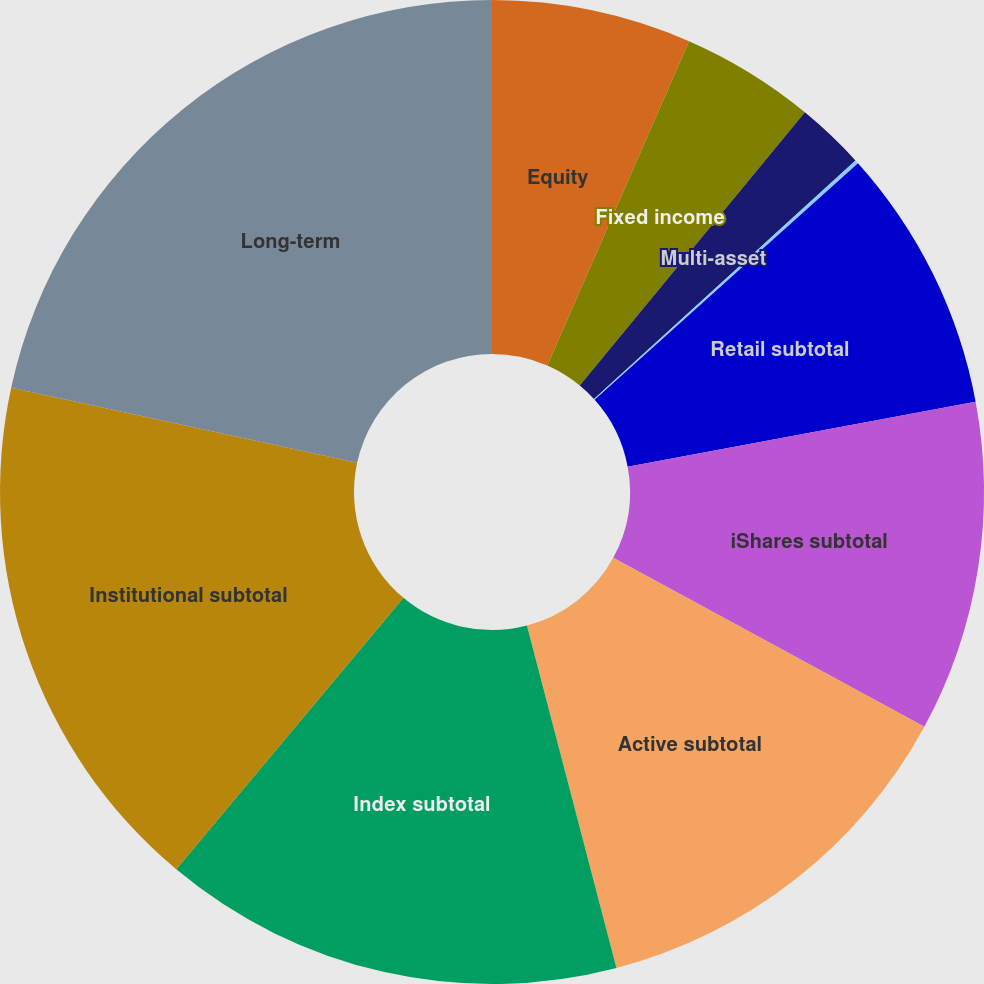Convert chart to OTSL. <chart><loc_0><loc_0><loc_500><loc_500><pie_chart><fcel>Equity<fcel>Fixed income<fcel>Multi-asset<fcel>Alternatives<fcel>Retail subtotal<fcel>iShares subtotal<fcel>Active subtotal<fcel>Index subtotal<fcel>Institutional subtotal<fcel>Long-term<nl><fcel>6.56%<fcel>4.41%<fcel>2.26%<fcel>0.12%<fcel>8.71%<fcel>10.86%<fcel>13.01%<fcel>15.16%<fcel>17.31%<fcel>21.6%<nl></chart> 